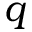Convert formula to latex. <formula><loc_0><loc_0><loc_500><loc_500>q</formula> 